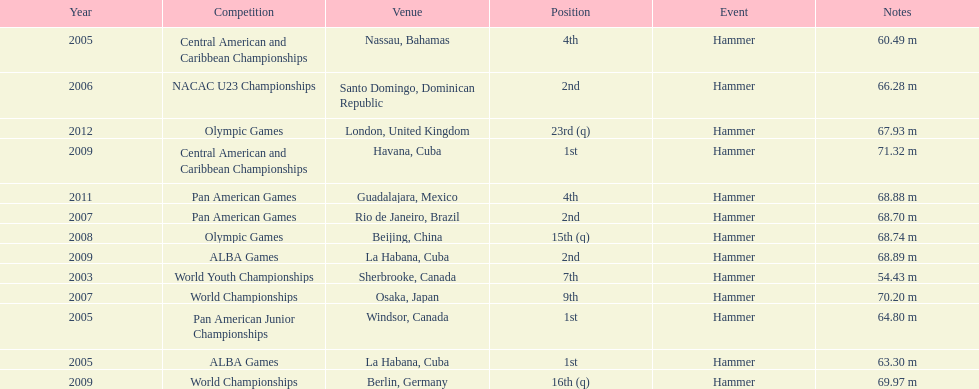How many times was the number one position earned? 3. Would you be able to parse every entry in this table? {'header': ['Year', 'Competition', 'Venue', 'Position', 'Event', 'Notes'], 'rows': [['2005', 'Central American and Caribbean Championships', 'Nassau, Bahamas', '4th', 'Hammer', '60.49 m'], ['2006', 'NACAC U23 Championships', 'Santo Domingo, Dominican Republic', '2nd', 'Hammer', '66.28 m'], ['2012', 'Olympic Games', 'London, United Kingdom', '23rd (q)', 'Hammer', '67.93 m'], ['2009', 'Central American and Caribbean Championships', 'Havana, Cuba', '1st', 'Hammer', '71.32 m'], ['2011', 'Pan American Games', 'Guadalajara, Mexico', '4th', 'Hammer', '68.88 m'], ['2007', 'Pan American Games', 'Rio de Janeiro, Brazil', '2nd', 'Hammer', '68.70 m'], ['2008', 'Olympic Games', 'Beijing, China', '15th (q)', 'Hammer', '68.74 m'], ['2009', 'ALBA Games', 'La Habana, Cuba', '2nd', 'Hammer', '68.89 m'], ['2003', 'World Youth Championships', 'Sherbrooke, Canada', '7th', 'Hammer', '54.43 m'], ['2007', 'World Championships', 'Osaka, Japan', '9th', 'Hammer', '70.20 m'], ['2005', 'Pan American Junior Championships', 'Windsor, Canada', '1st', 'Hammer', '64.80 m'], ['2005', 'ALBA Games', 'La Habana, Cuba', '1st', 'Hammer', '63.30 m'], ['2009', 'World Championships', 'Berlin, Germany', '16th (q)', 'Hammer', '69.97 m']]} 